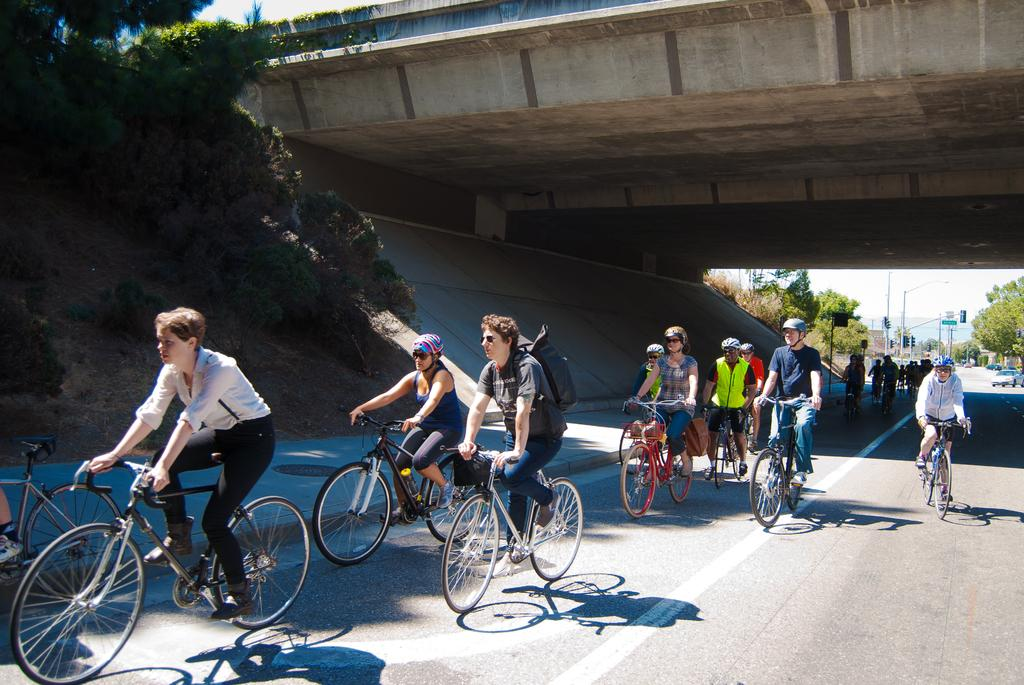What is the main feature of the image? There is a road in the image. What activity are the people engaged in? The people are sitting on a bicycle in the image. What type of vegetation is present on the left side of the image? There are trees on the left side of the image. What historical event is being commemorated by the stone monument in the image? There is no stone monument present in the image, so it is not possible to determine if any historical event is being commemorated. 